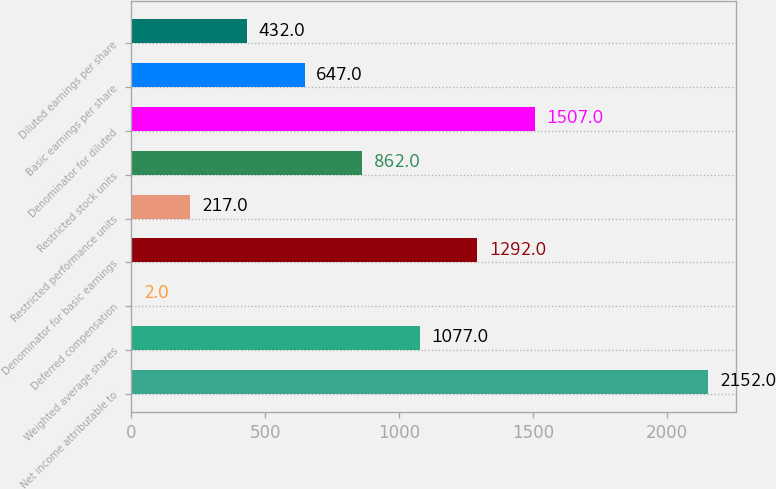<chart> <loc_0><loc_0><loc_500><loc_500><bar_chart><fcel>Net income attributable to<fcel>Weighted average shares<fcel>Deferred compensation<fcel>Denominator for basic earnings<fcel>Restricted performance units<fcel>Restricted stock units<fcel>Denominator for diluted<fcel>Basic earnings per share<fcel>Diluted earnings per share<nl><fcel>2152<fcel>1077<fcel>2<fcel>1292<fcel>217<fcel>862<fcel>1507<fcel>647<fcel>432<nl></chart> 